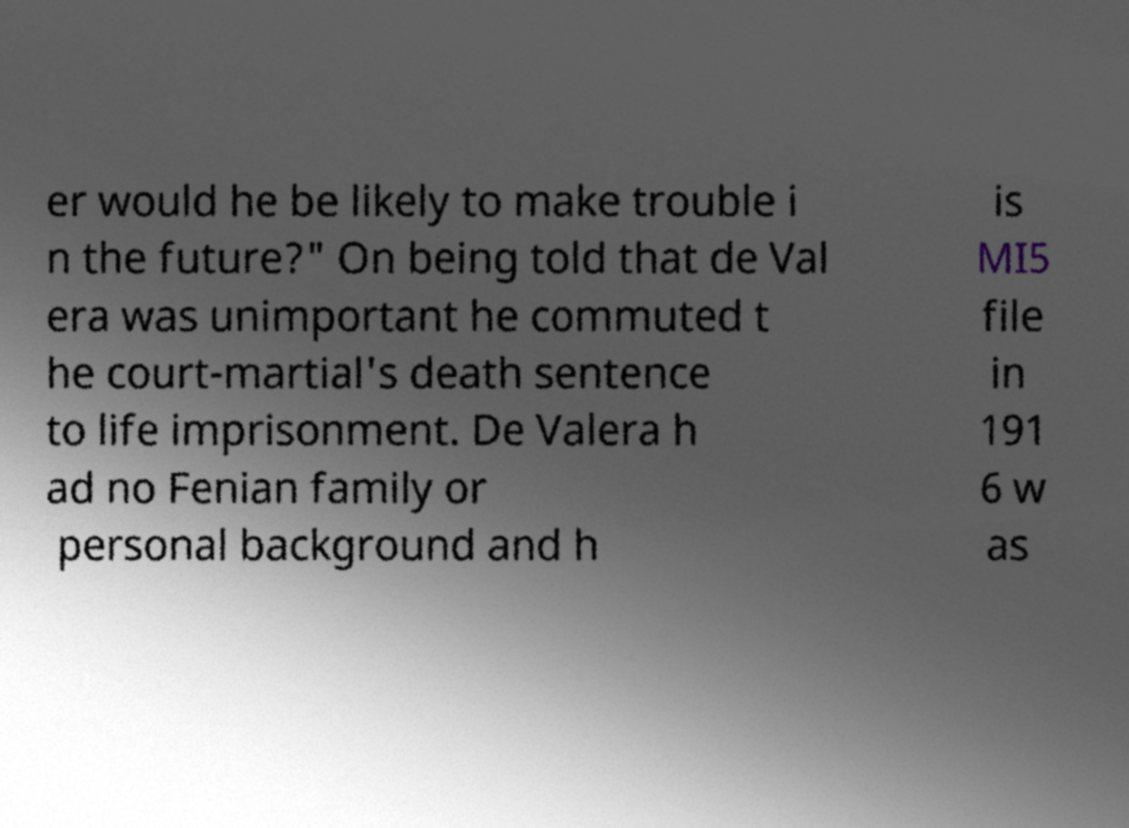Please read and relay the text visible in this image. What does it say? er would he be likely to make trouble i n the future?" On being told that de Val era was unimportant he commuted t he court-martial's death sentence to life imprisonment. De Valera h ad no Fenian family or personal background and h is MI5 file in 191 6 w as 